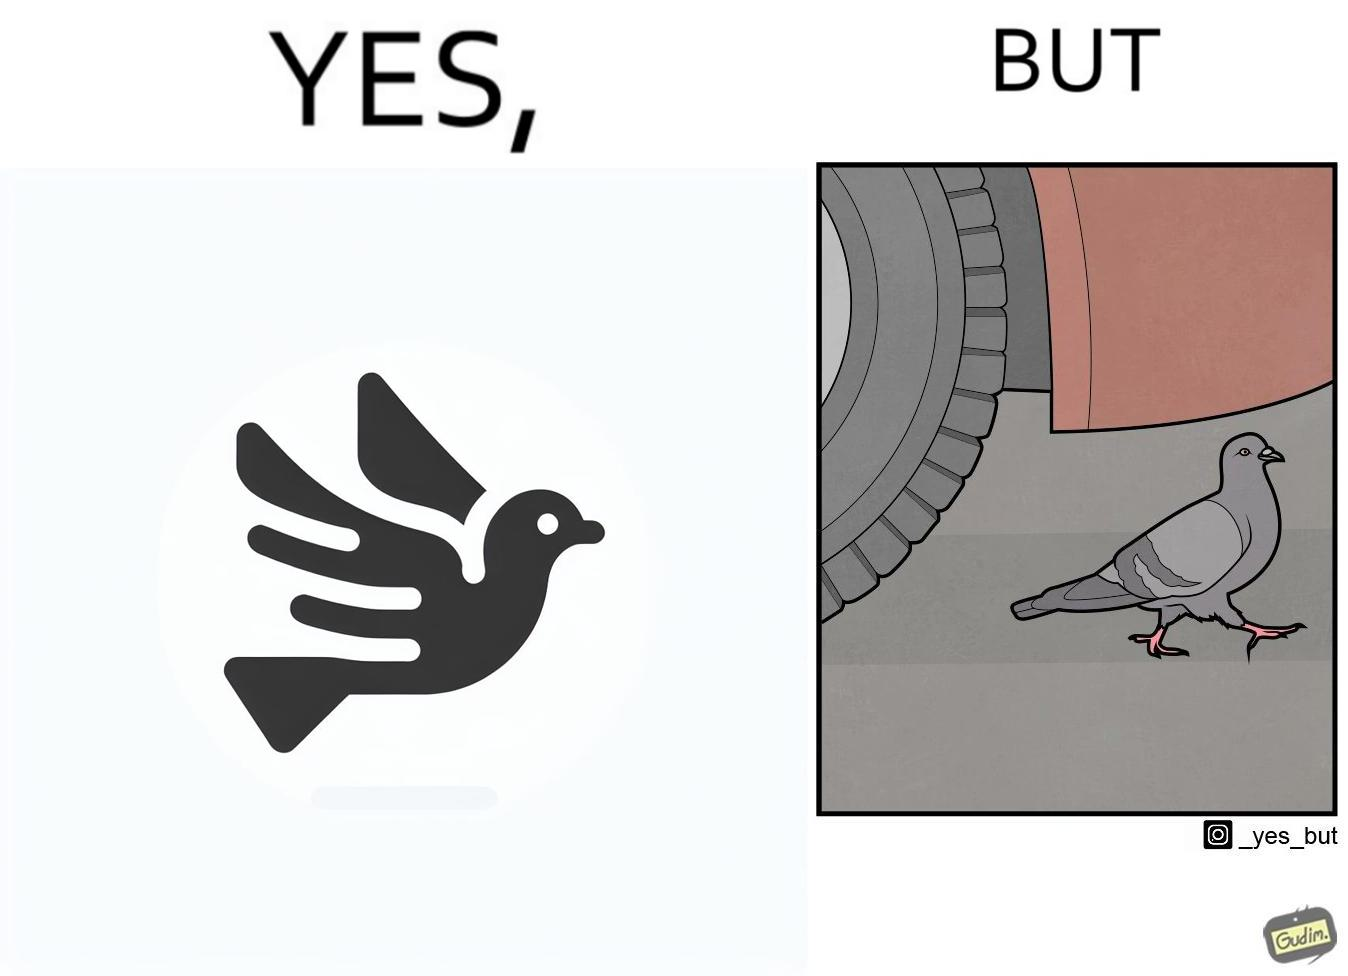Would you classify this image as satirical? Yes, this image is satirical. 